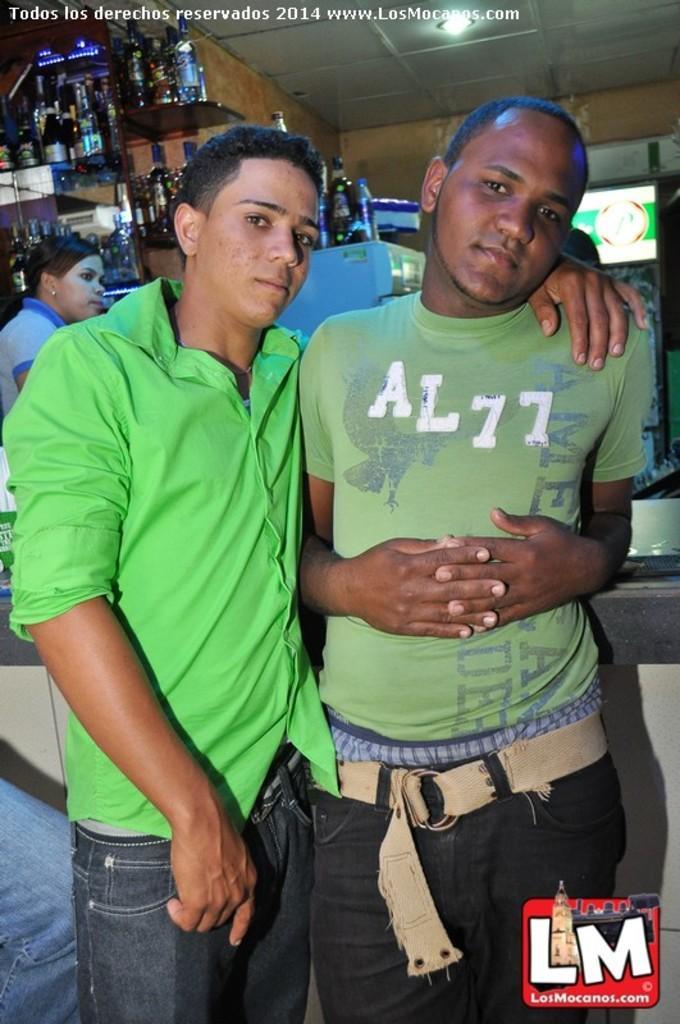Describe this image in one or two sentences. In this image we can see two persons wearing green color dress hugging each other and at the background of the image there is one person wearing blue color dress there are some bottles, refrigerator and roof. 